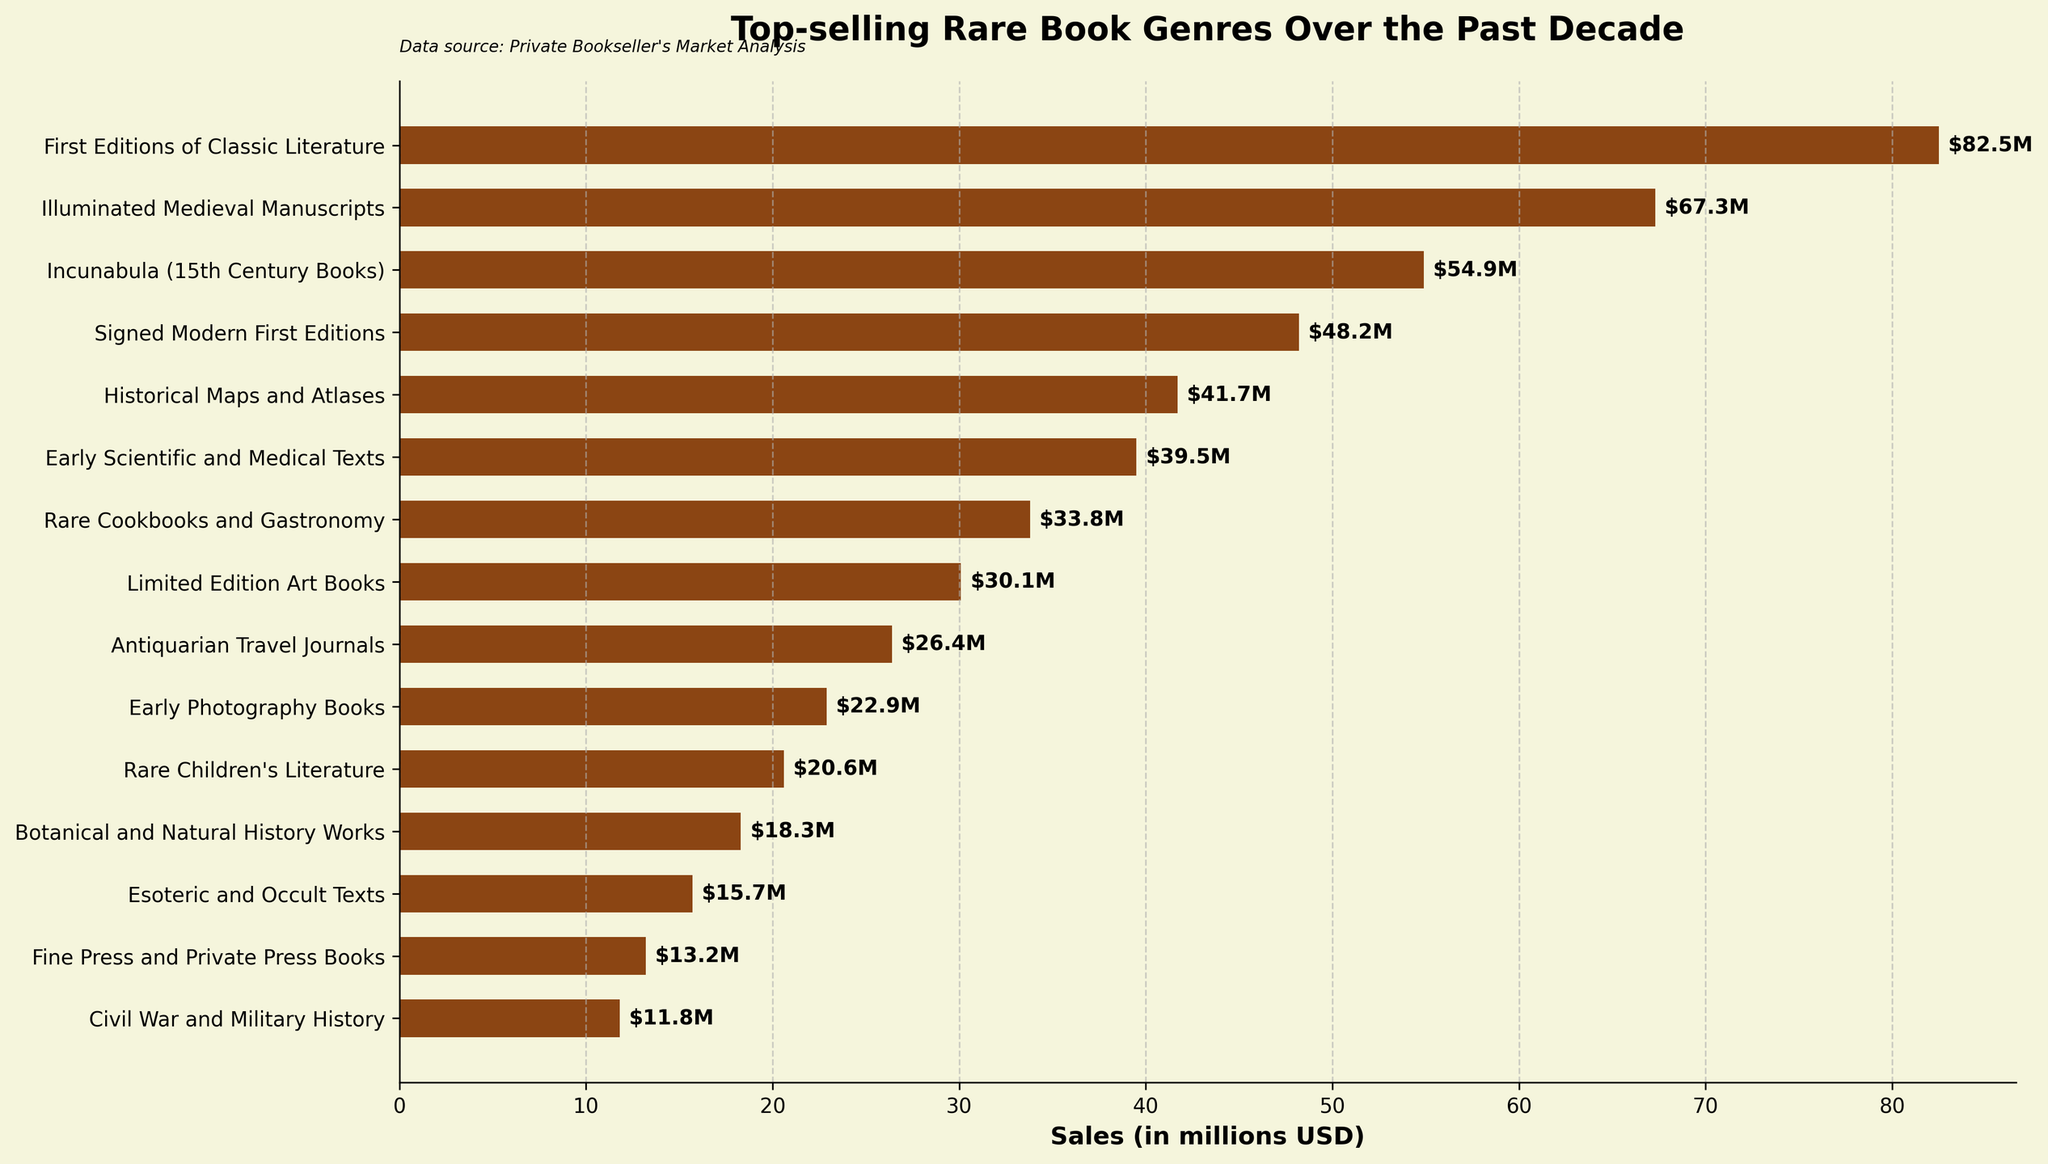What's the top-selling rare book genre over the past decade? The topmost bar on the chart represents the genre with the highest sales. Observing the bar chart, the highest bar corresponds to "First Editions of Classic Literature."
Answer: First Editions of Classic Literature Which genre has higher sales, Historical Maps and Atlases or Rare Cookbooks and Gastronomy? Compare the sales values of Historical Maps and Atlases (41.7 million USD) and Rare Cookbooks and Gastronomy (33.8 million USD) from the chart to determine which one is higher.
Answer: Historical Maps and Atlases What is the combined sales of Rare Children's Literature and Early Photography Books? To find the combined sales, add the values for Rare Children's Literature (20.6 million USD) and Early Photography Books (22.9 million USD). So, 20.6 + 22.9 = 43.5 million USD.
Answer: 43.5 million USD Rank the top three genres by sales. Identify the three largest bars and their corresponding genres. The top three are "First Editions of Classic Literature" (82.5 million USD), "Illuminated Medieval Manuscripts" (67.3 million USD), and "Incunabula (15th Century Books)" (54.9 million USD).
Answer: 1. First Editions of Classic Literature, 2. Illuminated Medieval Manuscripts, 3. Incunabula (15th Century Books) Is the sales value of Limited Edition Art Books closer to Early Scientific and Medical Texts or Antiquarian Travel Journals? Find the sales values: Limited Edition Art Books (30.1 million USD), Early Scientific and Medical Texts (39.5 million USD), Antiquarian Travel Journals (26.4 million USD). The difference between Limited Edition Art Books and Early Scientific and Medical Texts is 39.5 - 30.1 = 9.4 million USD. The difference between Limited Edition Art Books and Antiquarian Travel Journals is 30.1 - 26.4 = 3.7 million USD. The smaller difference indicates it is closer to Antiquarian Travel Journals.
Answer: Antiquarian Travel Journals How much more in sales did Incunabula (15th Century Books) generate compared to Fine Press and Private Press Books? Subtract the sales of Fine Press and Private Press Books (13.2 million USD) from the sales of Incunabula (15th Century Books) (54.9 million USD). So, 54.9 - 13.2 = 41.7 million USD.
Answer: 41.7 million USD What percentage of the total top-selling rare book sales over the past decade is attributed to Signed Modern First Editions? First, sum the sales of all genres. Then, divide the sales of Signed Modern First Editions (48.2 million USD) by the total sales and multiply by 100. Total sales = 82.5 + 67.3 + 54.9 + 48.2 + 41.7 + 39.5 + 33.8 + 30.1 + 26.4 + 22.9 + 20.6 + 18.3 + 15.7 + 13.2 + 11.8 = 526.9 million USD. Percentage = (48.2 / 526.9) * 100 ≈ 9.15%.
Answer: 9.15% 